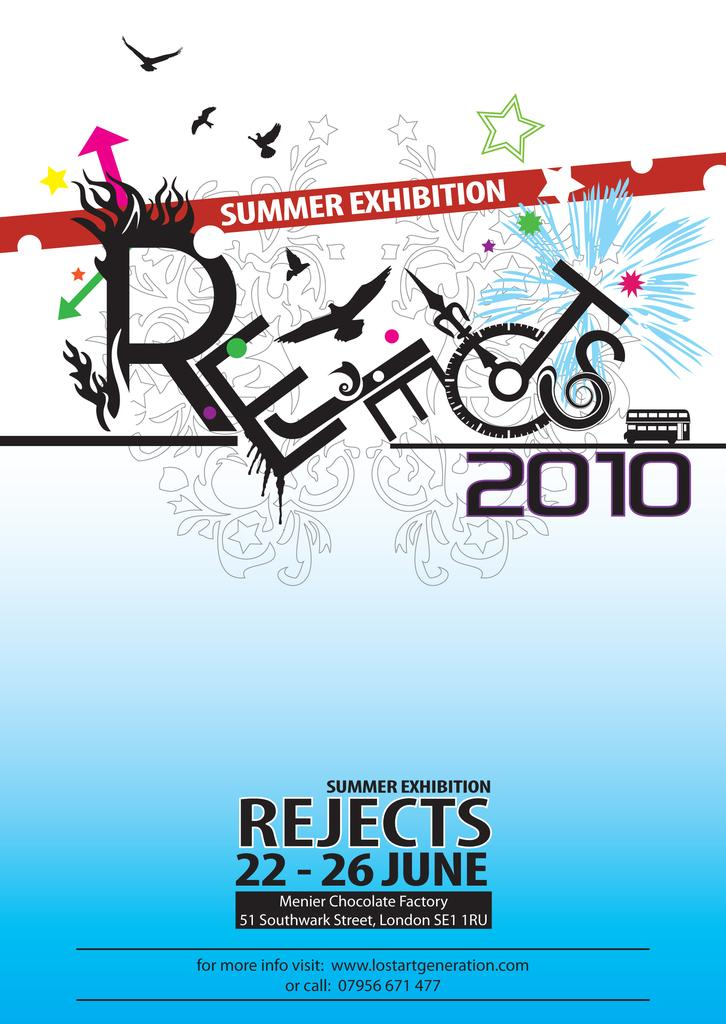<image>
Relay a brief, clear account of the picture shown. A poster for a summer exhibition in 2010 lists dates in June. 